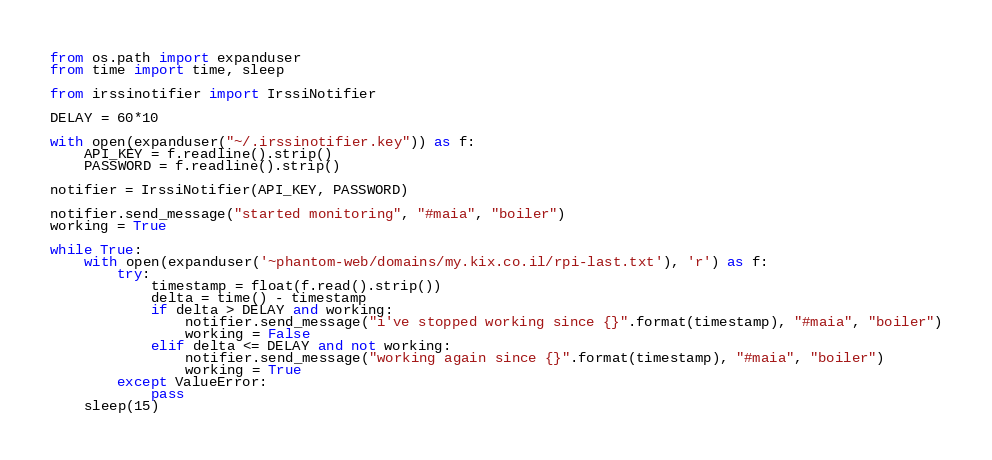Convert code to text. <code><loc_0><loc_0><loc_500><loc_500><_Python_>from os.path import expanduser
from time import time, sleep

from irssinotifier import IrssiNotifier

DELAY = 60*10

with open(expanduser("~/.irssinotifier.key")) as f:
    API_KEY = f.readline().strip()
    PASSWORD = f.readline().strip()

notifier = IrssiNotifier(API_KEY, PASSWORD)

notifier.send_message("started monitoring", "#maia", "boiler")
working = True

while True:
    with open(expanduser('~phantom-web/domains/my.kix.co.il/rpi-last.txt'), 'r') as f:
        try:
            timestamp = float(f.read().strip())
            delta = time() - timestamp
            if delta > DELAY and working:
                notifier.send_message("i've stopped working since {}".format(timestamp), "#maia", "boiler")
                working = False
            elif delta <= DELAY and not working:
                notifier.send_message("working again since {}".format(timestamp), "#maia", "boiler")
                working = True
        except ValueError:
            pass
    sleep(15)
</code> 